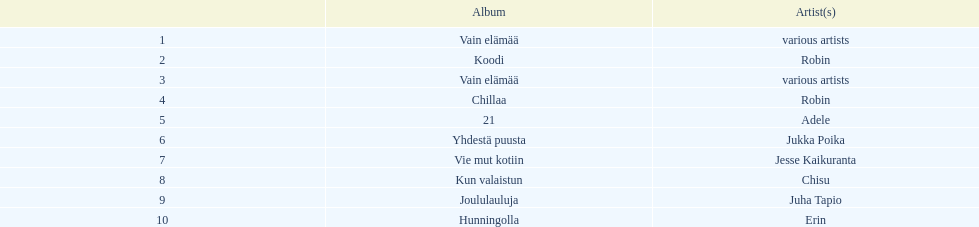Which sold better, hunningolla or vain elamaa? Vain elämää. 